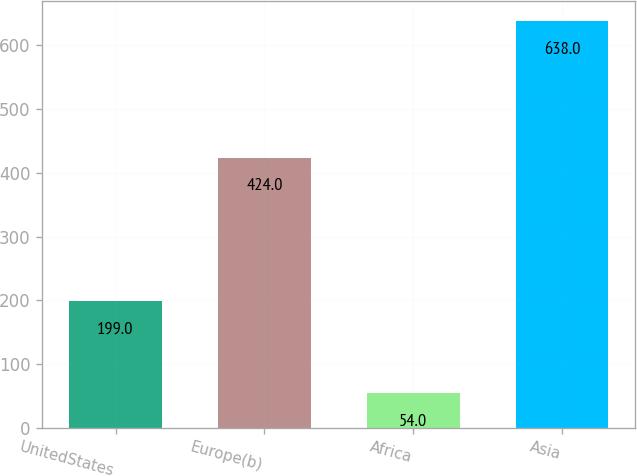Convert chart. <chart><loc_0><loc_0><loc_500><loc_500><bar_chart><fcel>UnitedStates<fcel>Europe(b)<fcel>Africa<fcel>Asia<nl><fcel>199<fcel>424<fcel>54<fcel>638<nl></chart> 